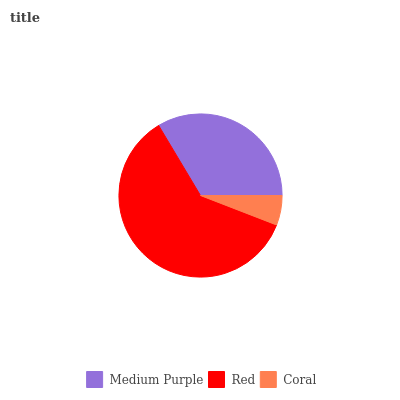Is Coral the minimum?
Answer yes or no. Yes. Is Red the maximum?
Answer yes or no. Yes. Is Red the minimum?
Answer yes or no. No. Is Coral the maximum?
Answer yes or no. No. Is Red greater than Coral?
Answer yes or no. Yes. Is Coral less than Red?
Answer yes or no. Yes. Is Coral greater than Red?
Answer yes or no. No. Is Red less than Coral?
Answer yes or no. No. Is Medium Purple the high median?
Answer yes or no. Yes. Is Medium Purple the low median?
Answer yes or no. Yes. Is Coral the high median?
Answer yes or no. No. Is Red the low median?
Answer yes or no. No. 